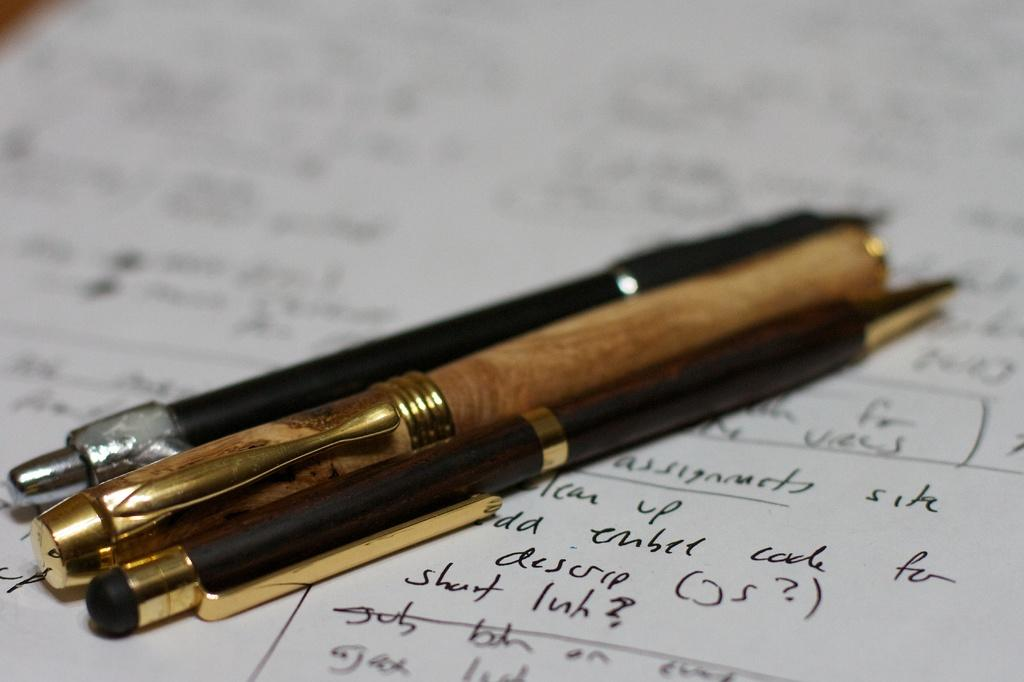<image>
Describe the image concisely. Three fancy writing pens laying on a handwritten page with the word "up" on the page. 